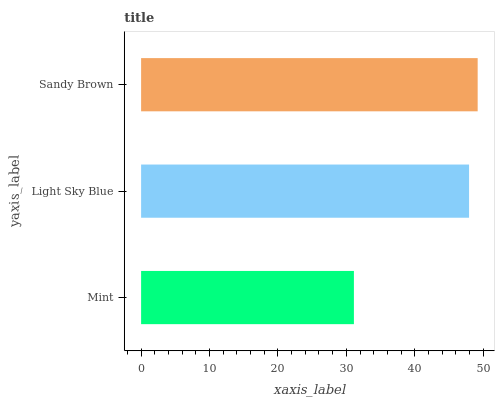Is Mint the minimum?
Answer yes or no. Yes. Is Sandy Brown the maximum?
Answer yes or no. Yes. Is Light Sky Blue the minimum?
Answer yes or no. No. Is Light Sky Blue the maximum?
Answer yes or no. No. Is Light Sky Blue greater than Mint?
Answer yes or no. Yes. Is Mint less than Light Sky Blue?
Answer yes or no. Yes. Is Mint greater than Light Sky Blue?
Answer yes or no. No. Is Light Sky Blue less than Mint?
Answer yes or no. No. Is Light Sky Blue the high median?
Answer yes or no. Yes. Is Light Sky Blue the low median?
Answer yes or no. Yes. Is Mint the high median?
Answer yes or no. No. Is Mint the low median?
Answer yes or no. No. 